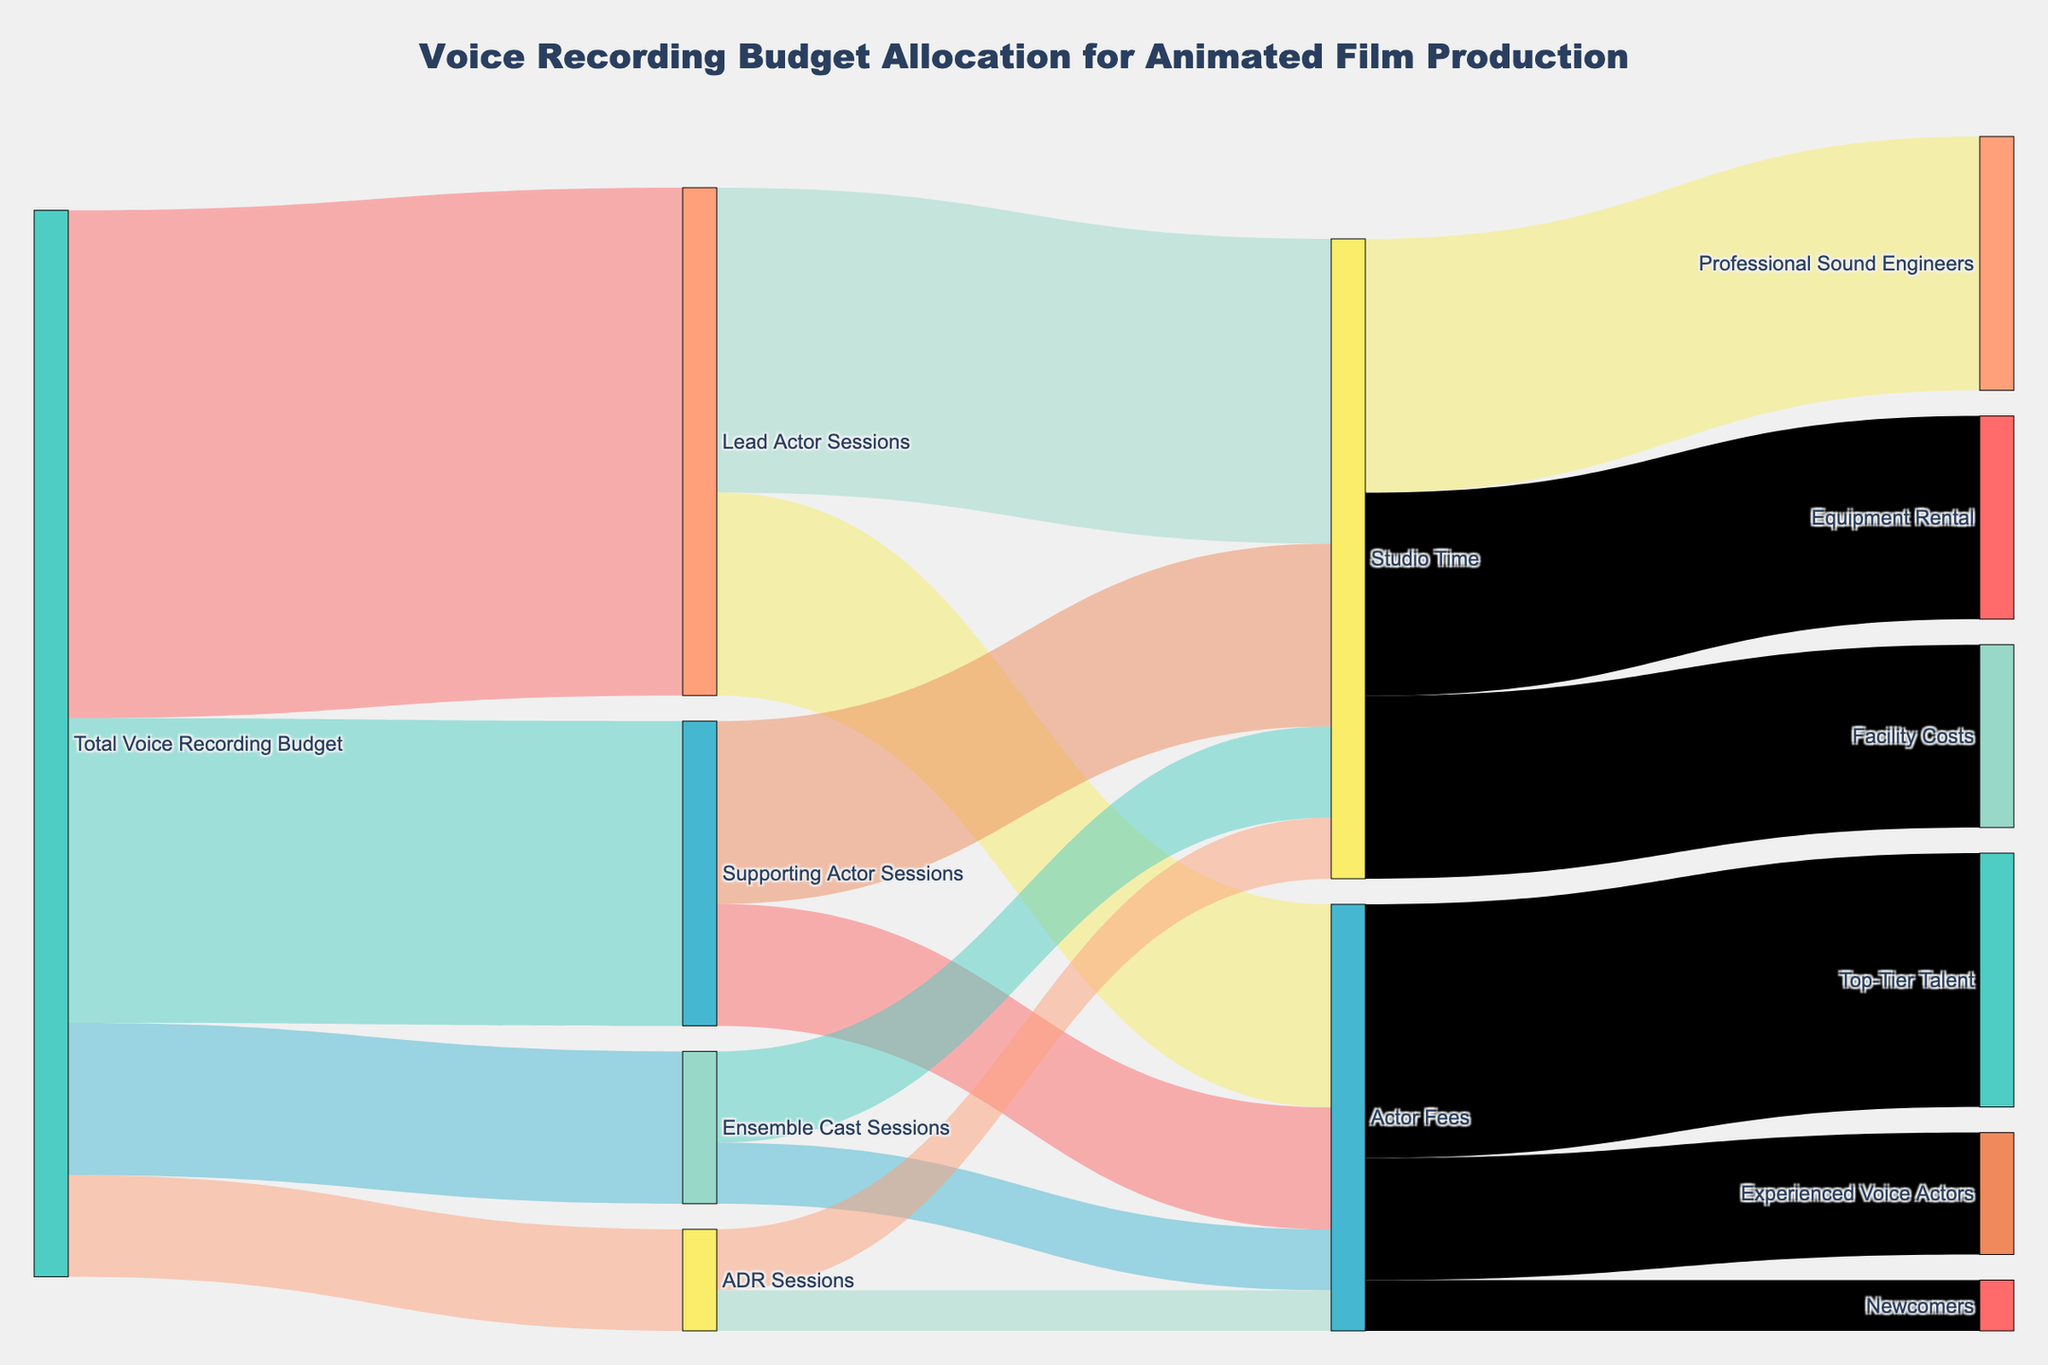What is the title of the diagram? The title of the diagram is written at the top center in a larger font.
Answer: Voice Recording Budget Allocation for Animated Film Production How much of the total voice recording budget is allocated to ADR Sessions? Identify the value next to ADR Sessions which connects from the Total Voice Recording Budget.
Answer: 100000 What are the categories funded by the total voice recording budget, and how much does each receive? Identify the outgoing links from Total Voice Recording Budget with their respective values.
Answer: Lead Actor Sessions: 500000, Supporting Actor Sessions: 300000, Ensemble Cast Sessions: 150000, ADR Sessions: 100000 How does the budget allocation for Studio Time differ between Lead Actor Sessions and Supporting Actor Sessions? Compare the values of Studio Time linking from Lead Actor Sessions and Supporting Actor Sessions.
Answer: 300000 for Lead Actor Sessions, 180000 for Supporting Actor Sessions What is the combined budget allocation for Studio Time? Sum the values allocated to Studio Time from all the session categories (Lead, Supporting, Ensemble, ADR).
Answer: 630000 Which category has the highest budget allocation from Actor Fees? Identify the largest value among the subcategories under Actor Fees.
Answer: Top-Tier Talent What is the total budget allocated to Equipment Rental? Identify the value next to Equipment Rental as part of the Studio Time categories.
Answer: 200000 How does the allocation for Experienced Voice Actors compare to Newcomers? Compare the values of Experienced Voice Actors and Newcomers subcategories.
Answer: 120000 vs 50000 What proportion of the entire voice recording budget is allocated to Supporting Actor Sessions? Calculate the percentage by dividing the Supporting Actor Sessions budget by the total budget.
Answer: 30% Which subcategory within Studio Time has the smallest allocation, and how much is it? Identify the smallest value among the subcategories under Studio Time.
Answer: Facility Costs: 180000 